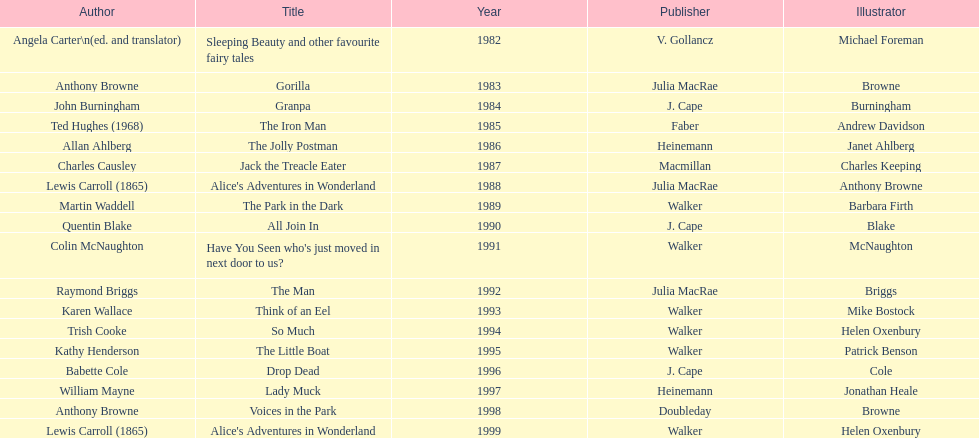What's the difference in years between angela carter's title and anthony browne's? 1. 